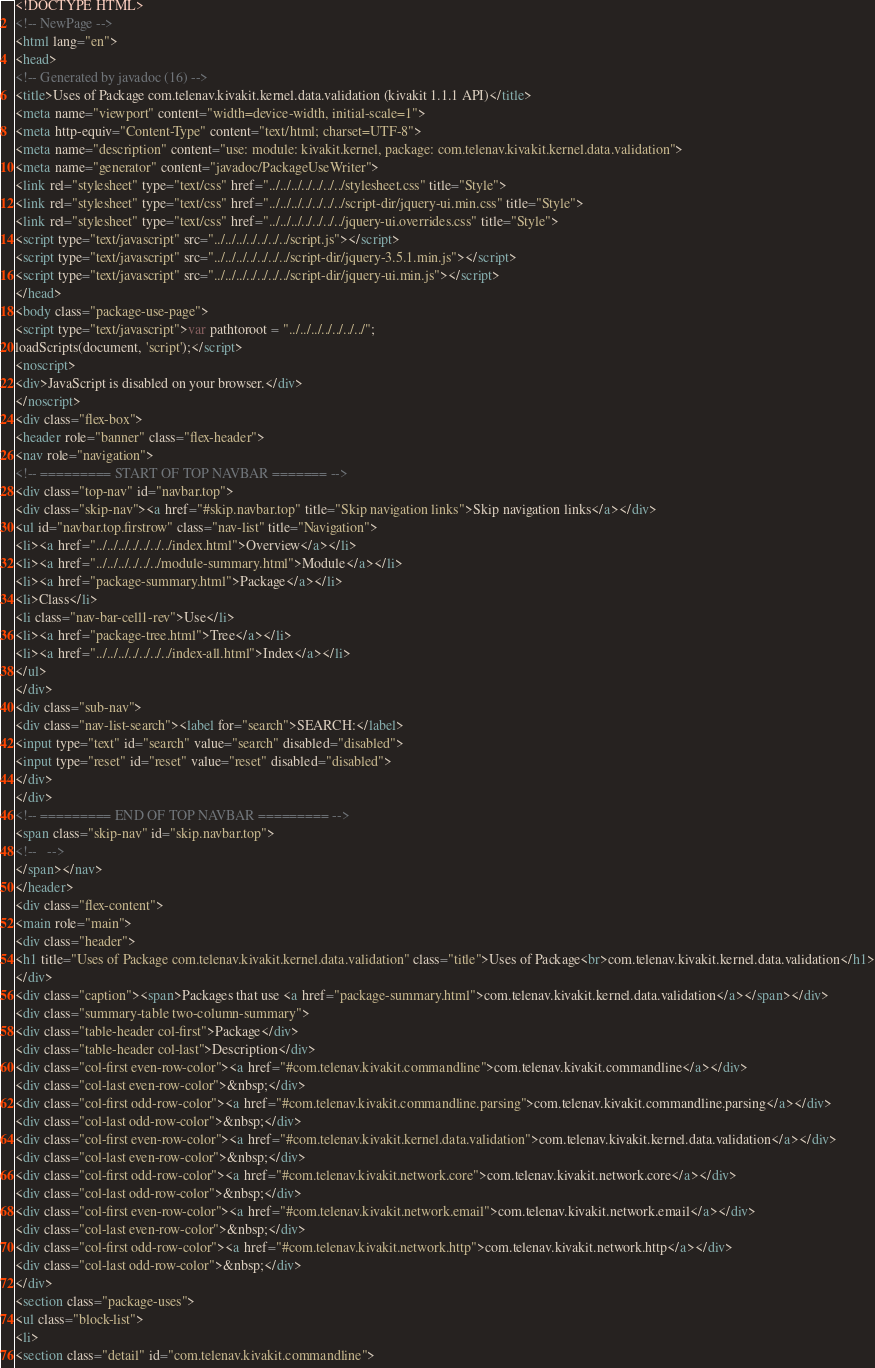Convert code to text. <code><loc_0><loc_0><loc_500><loc_500><_HTML_><!DOCTYPE HTML>
<!-- NewPage -->
<html lang="en">
<head>
<!-- Generated by javadoc (16) -->
<title>Uses of Package com.telenav.kivakit.kernel.data.validation (kivakit 1.1.1 API)</title>
<meta name="viewport" content="width=device-width, initial-scale=1">
<meta http-equiv="Content-Type" content="text/html; charset=UTF-8">
<meta name="description" content="use: module: kivakit.kernel, package: com.telenav.kivakit.kernel.data.validation">
<meta name="generator" content="javadoc/PackageUseWriter">
<link rel="stylesheet" type="text/css" href="../../../../../../../stylesheet.css" title="Style">
<link rel="stylesheet" type="text/css" href="../../../../../../../script-dir/jquery-ui.min.css" title="Style">
<link rel="stylesheet" type="text/css" href="../../../../../../../jquery-ui.overrides.css" title="Style">
<script type="text/javascript" src="../../../../../../../script.js"></script>
<script type="text/javascript" src="../../../../../../../script-dir/jquery-3.5.1.min.js"></script>
<script type="text/javascript" src="../../../../../../../script-dir/jquery-ui.min.js"></script>
</head>
<body class="package-use-page">
<script type="text/javascript">var pathtoroot = "../../../../../../../";
loadScripts(document, 'script');</script>
<noscript>
<div>JavaScript is disabled on your browser.</div>
</noscript>
<div class="flex-box">
<header role="banner" class="flex-header">
<nav role="navigation">
<!-- ========= START OF TOP NAVBAR ======= -->
<div class="top-nav" id="navbar.top">
<div class="skip-nav"><a href="#skip.navbar.top" title="Skip navigation links">Skip navigation links</a></div>
<ul id="navbar.top.firstrow" class="nav-list" title="Navigation">
<li><a href="../../../../../../../index.html">Overview</a></li>
<li><a href="../../../../../../module-summary.html">Module</a></li>
<li><a href="package-summary.html">Package</a></li>
<li>Class</li>
<li class="nav-bar-cell1-rev">Use</li>
<li><a href="package-tree.html">Tree</a></li>
<li><a href="../../../../../../../index-all.html">Index</a></li>
</ul>
</div>
<div class="sub-nav">
<div class="nav-list-search"><label for="search">SEARCH:</label>
<input type="text" id="search" value="search" disabled="disabled">
<input type="reset" id="reset" value="reset" disabled="disabled">
</div>
</div>
<!-- ========= END OF TOP NAVBAR ========= -->
<span class="skip-nav" id="skip.navbar.top">
<!--   -->
</span></nav>
</header>
<div class="flex-content">
<main role="main">
<div class="header">
<h1 title="Uses of Package com.telenav.kivakit.kernel.data.validation" class="title">Uses of Package<br>com.telenav.kivakit.kernel.data.validation</h1>
</div>
<div class="caption"><span>Packages that use <a href="package-summary.html">com.telenav.kivakit.kernel.data.validation</a></span></div>
<div class="summary-table two-column-summary">
<div class="table-header col-first">Package</div>
<div class="table-header col-last">Description</div>
<div class="col-first even-row-color"><a href="#com.telenav.kivakit.commandline">com.telenav.kivakit.commandline</a></div>
<div class="col-last even-row-color">&nbsp;</div>
<div class="col-first odd-row-color"><a href="#com.telenav.kivakit.commandline.parsing">com.telenav.kivakit.commandline.parsing</a></div>
<div class="col-last odd-row-color">&nbsp;</div>
<div class="col-first even-row-color"><a href="#com.telenav.kivakit.kernel.data.validation">com.telenav.kivakit.kernel.data.validation</a></div>
<div class="col-last even-row-color">&nbsp;</div>
<div class="col-first odd-row-color"><a href="#com.telenav.kivakit.network.core">com.telenav.kivakit.network.core</a></div>
<div class="col-last odd-row-color">&nbsp;</div>
<div class="col-first even-row-color"><a href="#com.telenav.kivakit.network.email">com.telenav.kivakit.network.email</a></div>
<div class="col-last even-row-color">&nbsp;</div>
<div class="col-first odd-row-color"><a href="#com.telenav.kivakit.network.http">com.telenav.kivakit.network.http</a></div>
<div class="col-last odd-row-color">&nbsp;</div>
</div>
<section class="package-uses">
<ul class="block-list">
<li>
<section class="detail" id="com.telenav.kivakit.commandline"></code> 